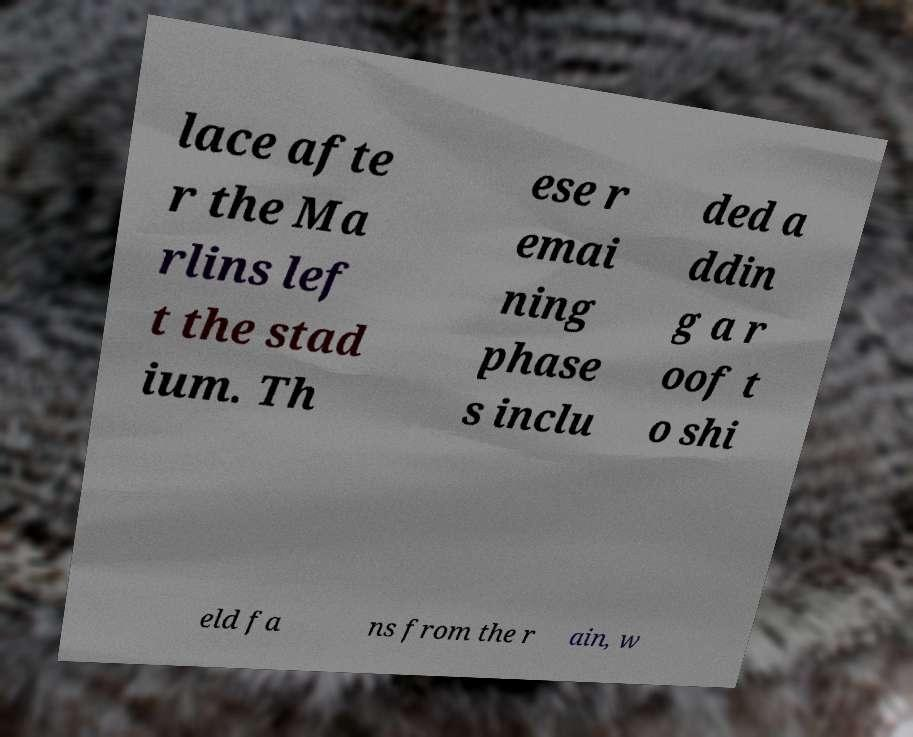What messages or text are displayed in this image? I need them in a readable, typed format. lace afte r the Ma rlins lef t the stad ium. Th ese r emai ning phase s inclu ded a ddin g a r oof t o shi eld fa ns from the r ain, w 